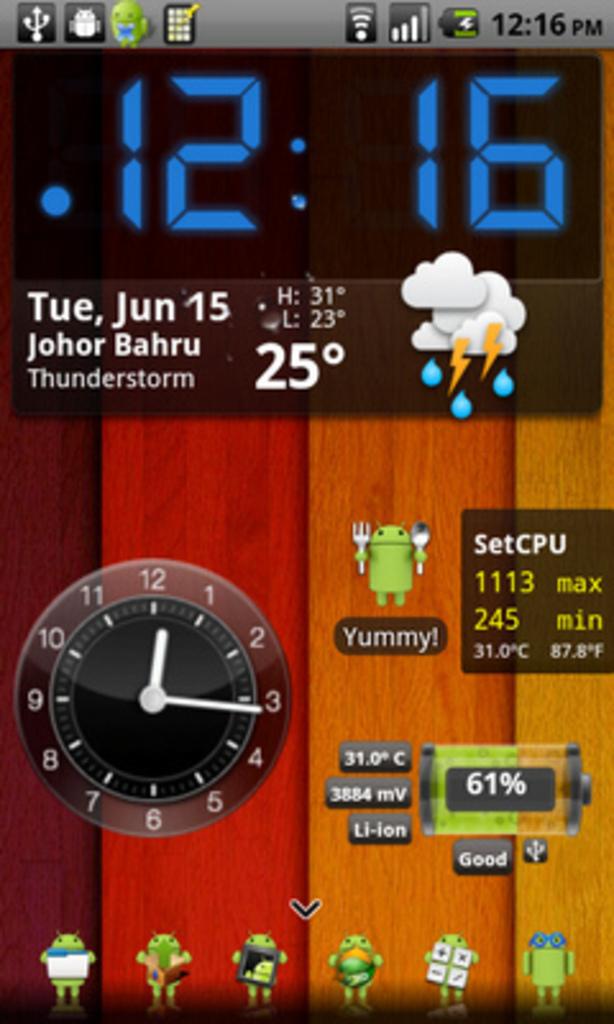What time was this screenshot taken?
Your answer should be compact. 12:16. What is the temperature?
Offer a terse response. 25. 